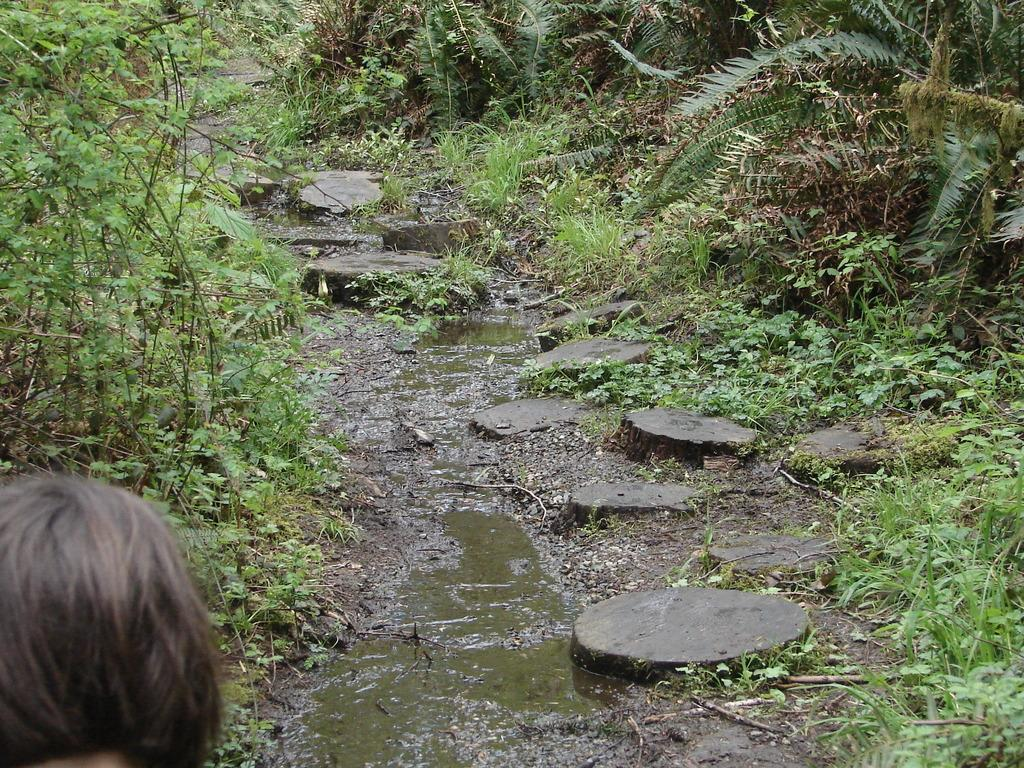What is a part of a person's body that can be seen in the image? There is a person's hair in the image. What can be seen on both sides of the path in the image? There are plants and trees on both sides of the path in the image. What type of material is visible on the ground in the image? There are stones visible in the image. What country is the person from in the image? There is no information about the person's country of origin in the image. What type of work is the person doing in the image? There is no indication of the person's occupation or activity in the image. 